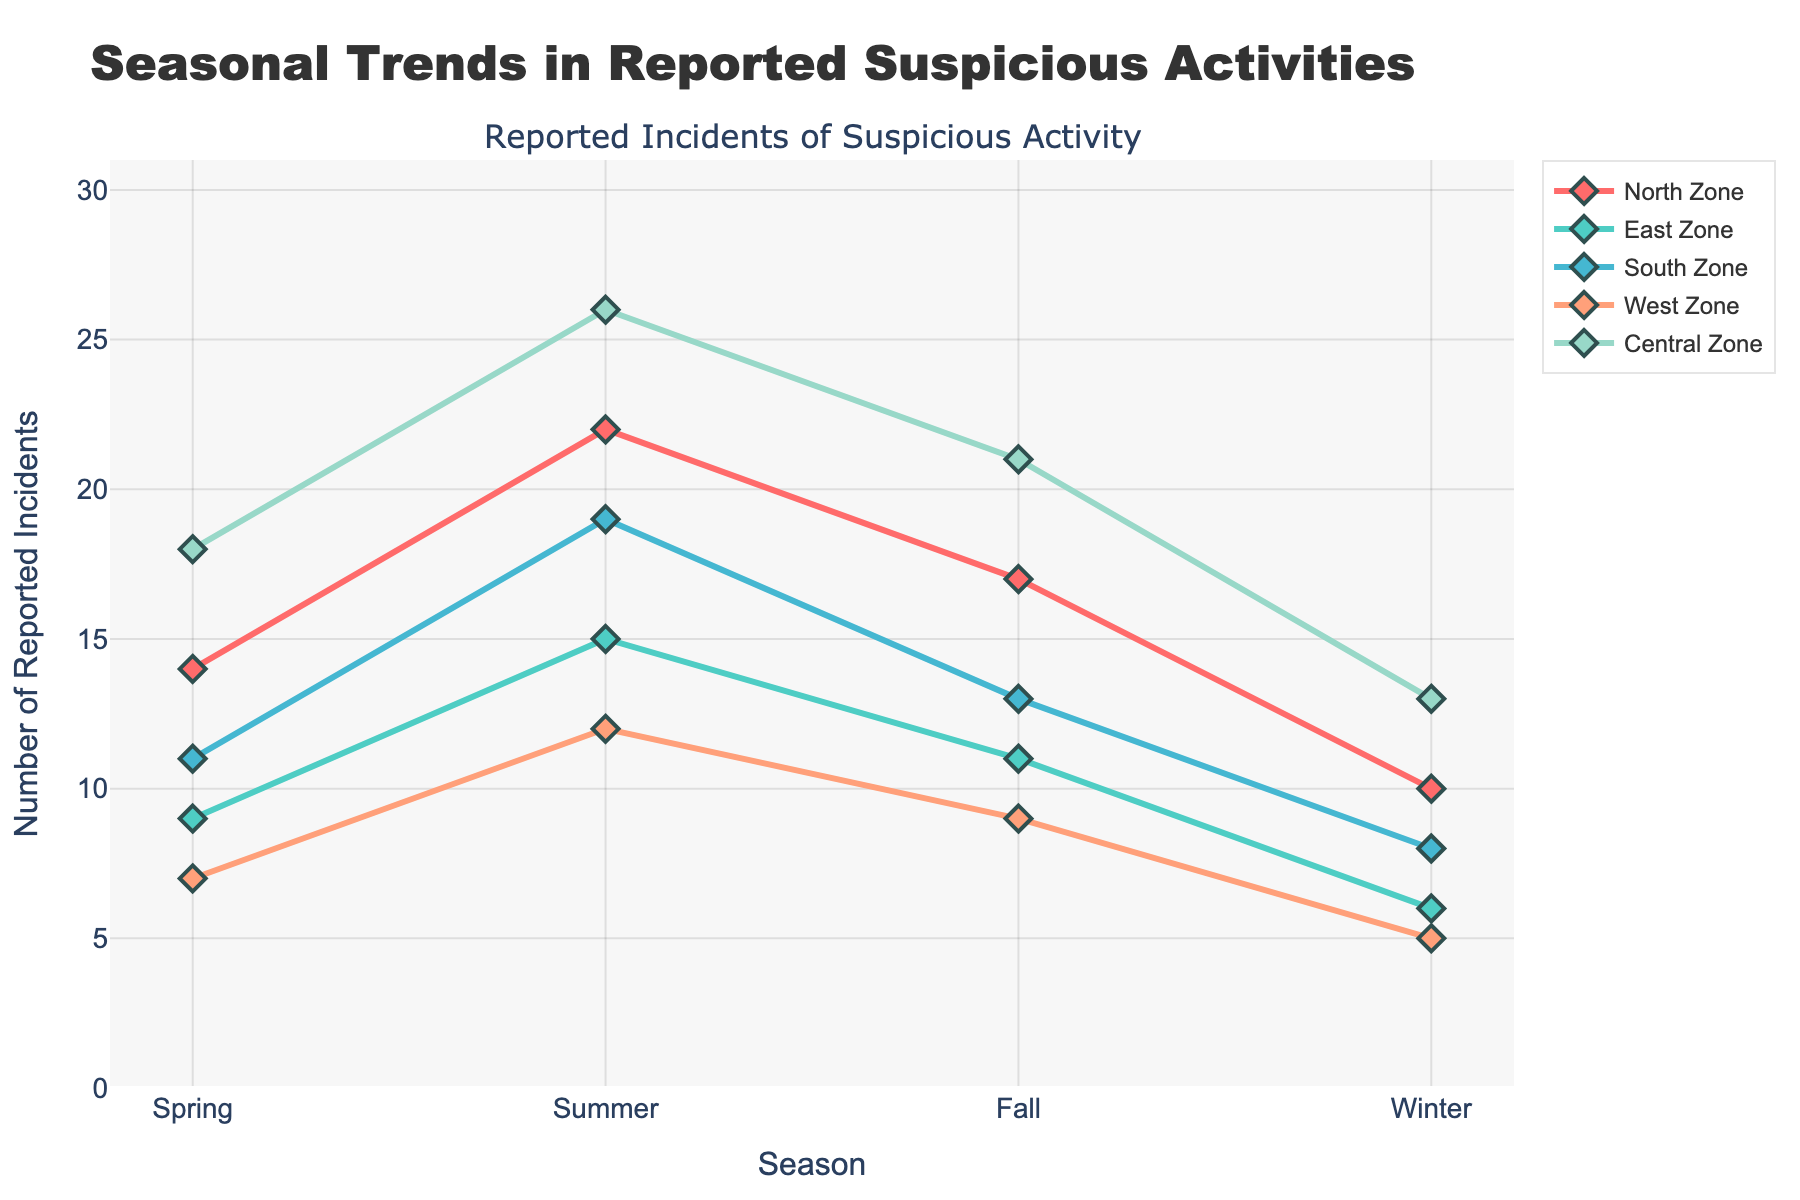Which season has the highest number of reported incidents in the North Zone? By looking at the North Zone line, the highest point is in the Summer season.
Answer: Summer Which season has the lowest number of reported incidents in the West Zone? By checking the West Zone line, the lowest point is in the Winter season.
Answer: Winter What is the difference in the number of reported incidents between Summer and Winter in the Central Zone? The number of incidents in Summer is 26 and in Winter is 13, so the difference is 26 - 13 = 13.
Answer: 13 Compare the reported incidents in the South Zone during Fall and the East Zone during Spring. Which one is greater? In the South Zone during Fall, it's 13. In the East Zone during Spring, it's 9. Therefore, the South Zone during Fall has more incidents.
Answer: South Zone during Fall What is the total number of reported incidents across all seasons in the North Zone? Add the numbers: 14 (Spring) + 22 (Summer) + 17 (Fall) + 10 (Winter) = 63.
Answer: 63 In which season does the Central Zone see the maximum increase in reported incidents compared to the previous season? By checking the Central Zone line, the increase is: Spring to Summer (18 to 26, increase of 8), Summer to Fall (26 to 21, a decrease), Fall to Winter (21 to 13, a decrease). The maximum increase is from Spring to Summer.
Answer: Spring to Summer What is the average number of reported incidents in the West Zone across all seasons? Add the numbers: 7 (Spring) + 12 (Summer) + 9 (Fall) + 5 (Winter) = 33. Then, divide by 4 (number of seasons) to get the average: 33 / 4 = 8.25.
Answer: 8.25 Which zone had the largest fluctuation in the number of incidents reported between any two adjacent seasons? Largest fluctuation is the one with the highest difference. North Zone: max diff = 12, East Zone: max diff = 6, South Zone: max diff = 11, West Zone: max diff = 7, Central Zone: max diff = 13. Central Zone has the largest fluctuation (13 incidents between Winter and Spring).
Answer: Central Zone How many more incidents were reported in the Central Zone compared to the East Zone during Summer? Central Zone has 26 incidents in Summer while East Zone has 15. The difference is 26 - 15 = 11.
Answer: 11 